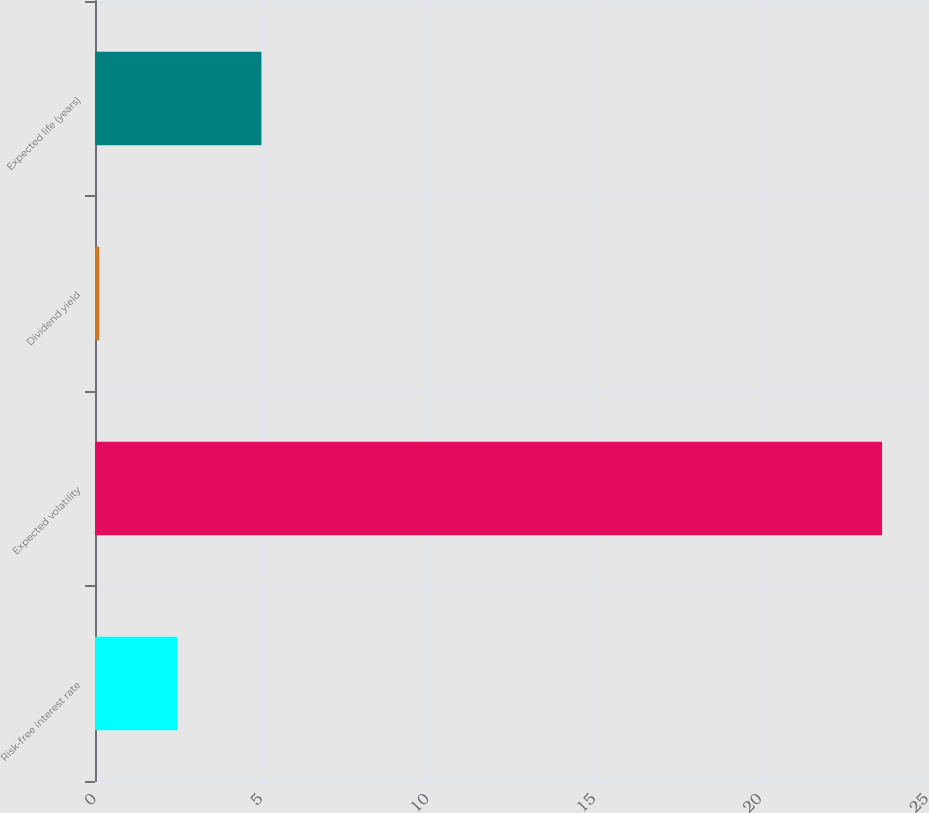Convert chart. <chart><loc_0><loc_0><loc_500><loc_500><bar_chart><fcel>Risk-free interest rate<fcel>Expected volatility<fcel>Dividend yield<fcel>Expected life (years)<nl><fcel>2.48<fcel>23.65<fcel>0.13<fcel>5<nl></chart> 